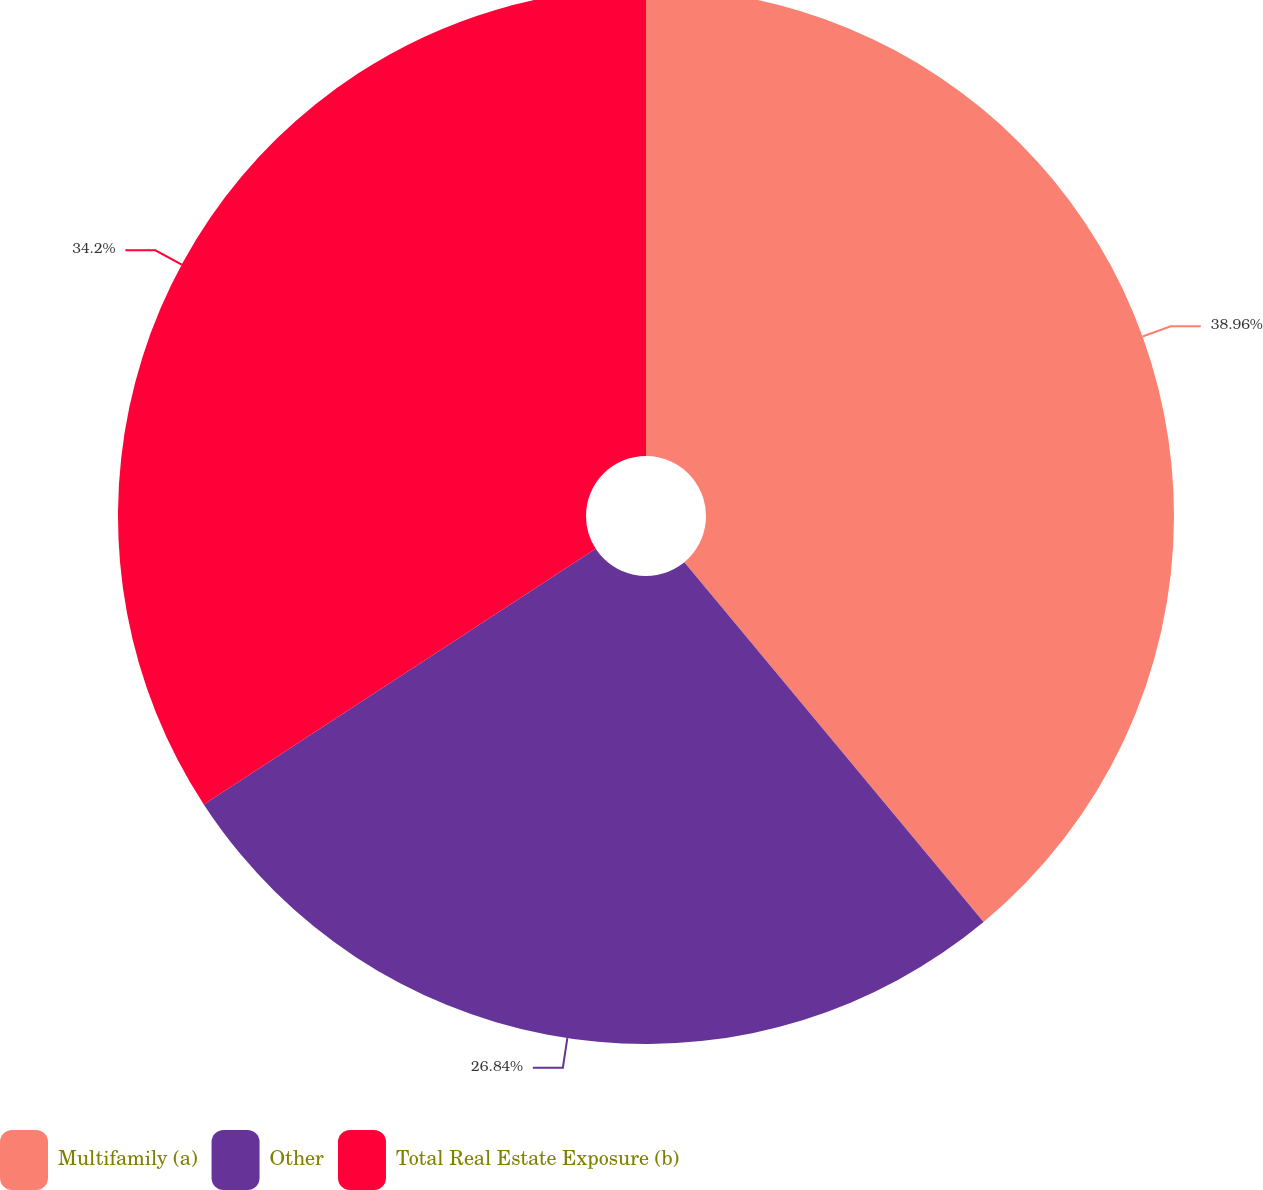<chart> <loc_0><loc_0><loc_500><loc_500><pie_chart><fcel>Multifamily (a)<fcel>Other<fcel>Total Real Estate Exposure (b)<nl><fcel>38.96%<fcel>26.84%<fcel>34.2%<nl></chart> 